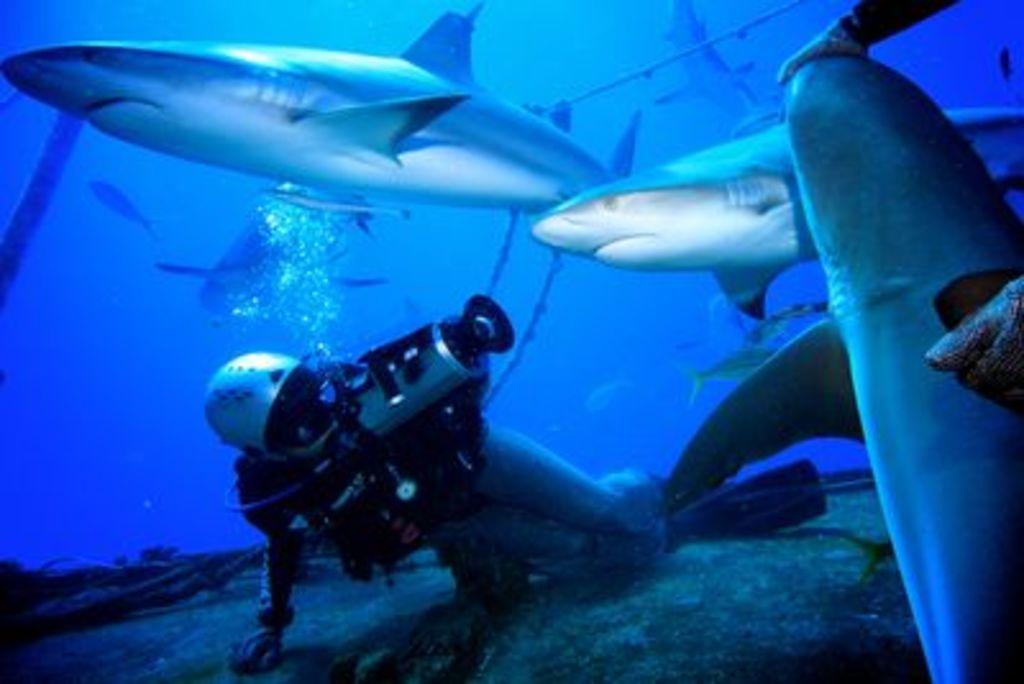Describe this image in one or two sentences. In the image I can see there is a person doing scuba diving under the water around him there are so many fishes. 